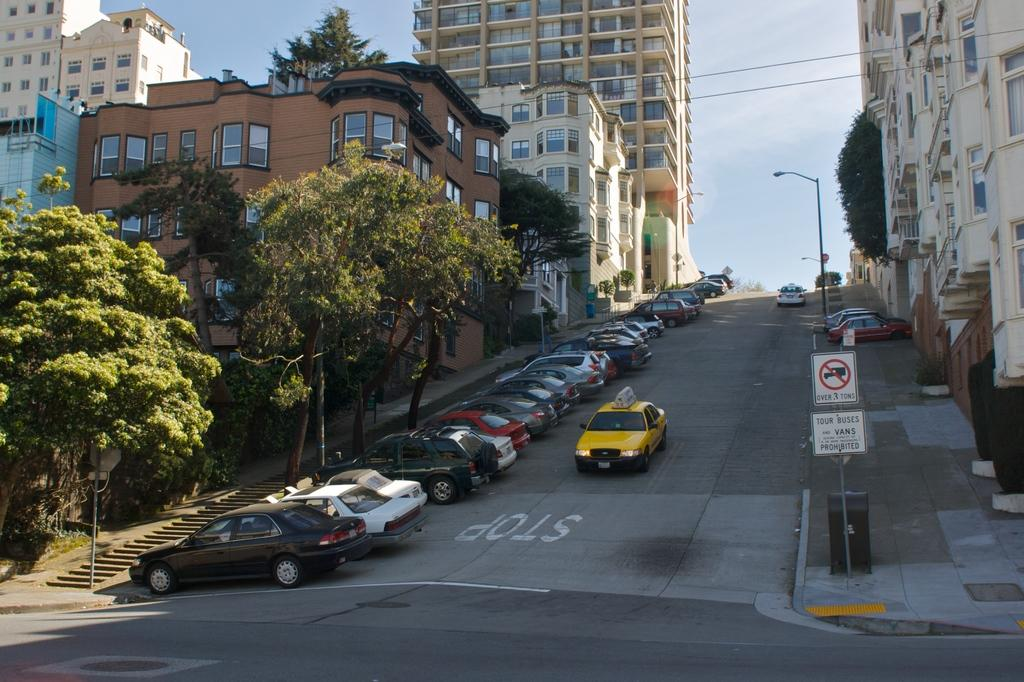<image>
Write a terse but informative summary of the picture. A yellow taxi is going down a hill with a sign that says no trucks over 3 tons. 